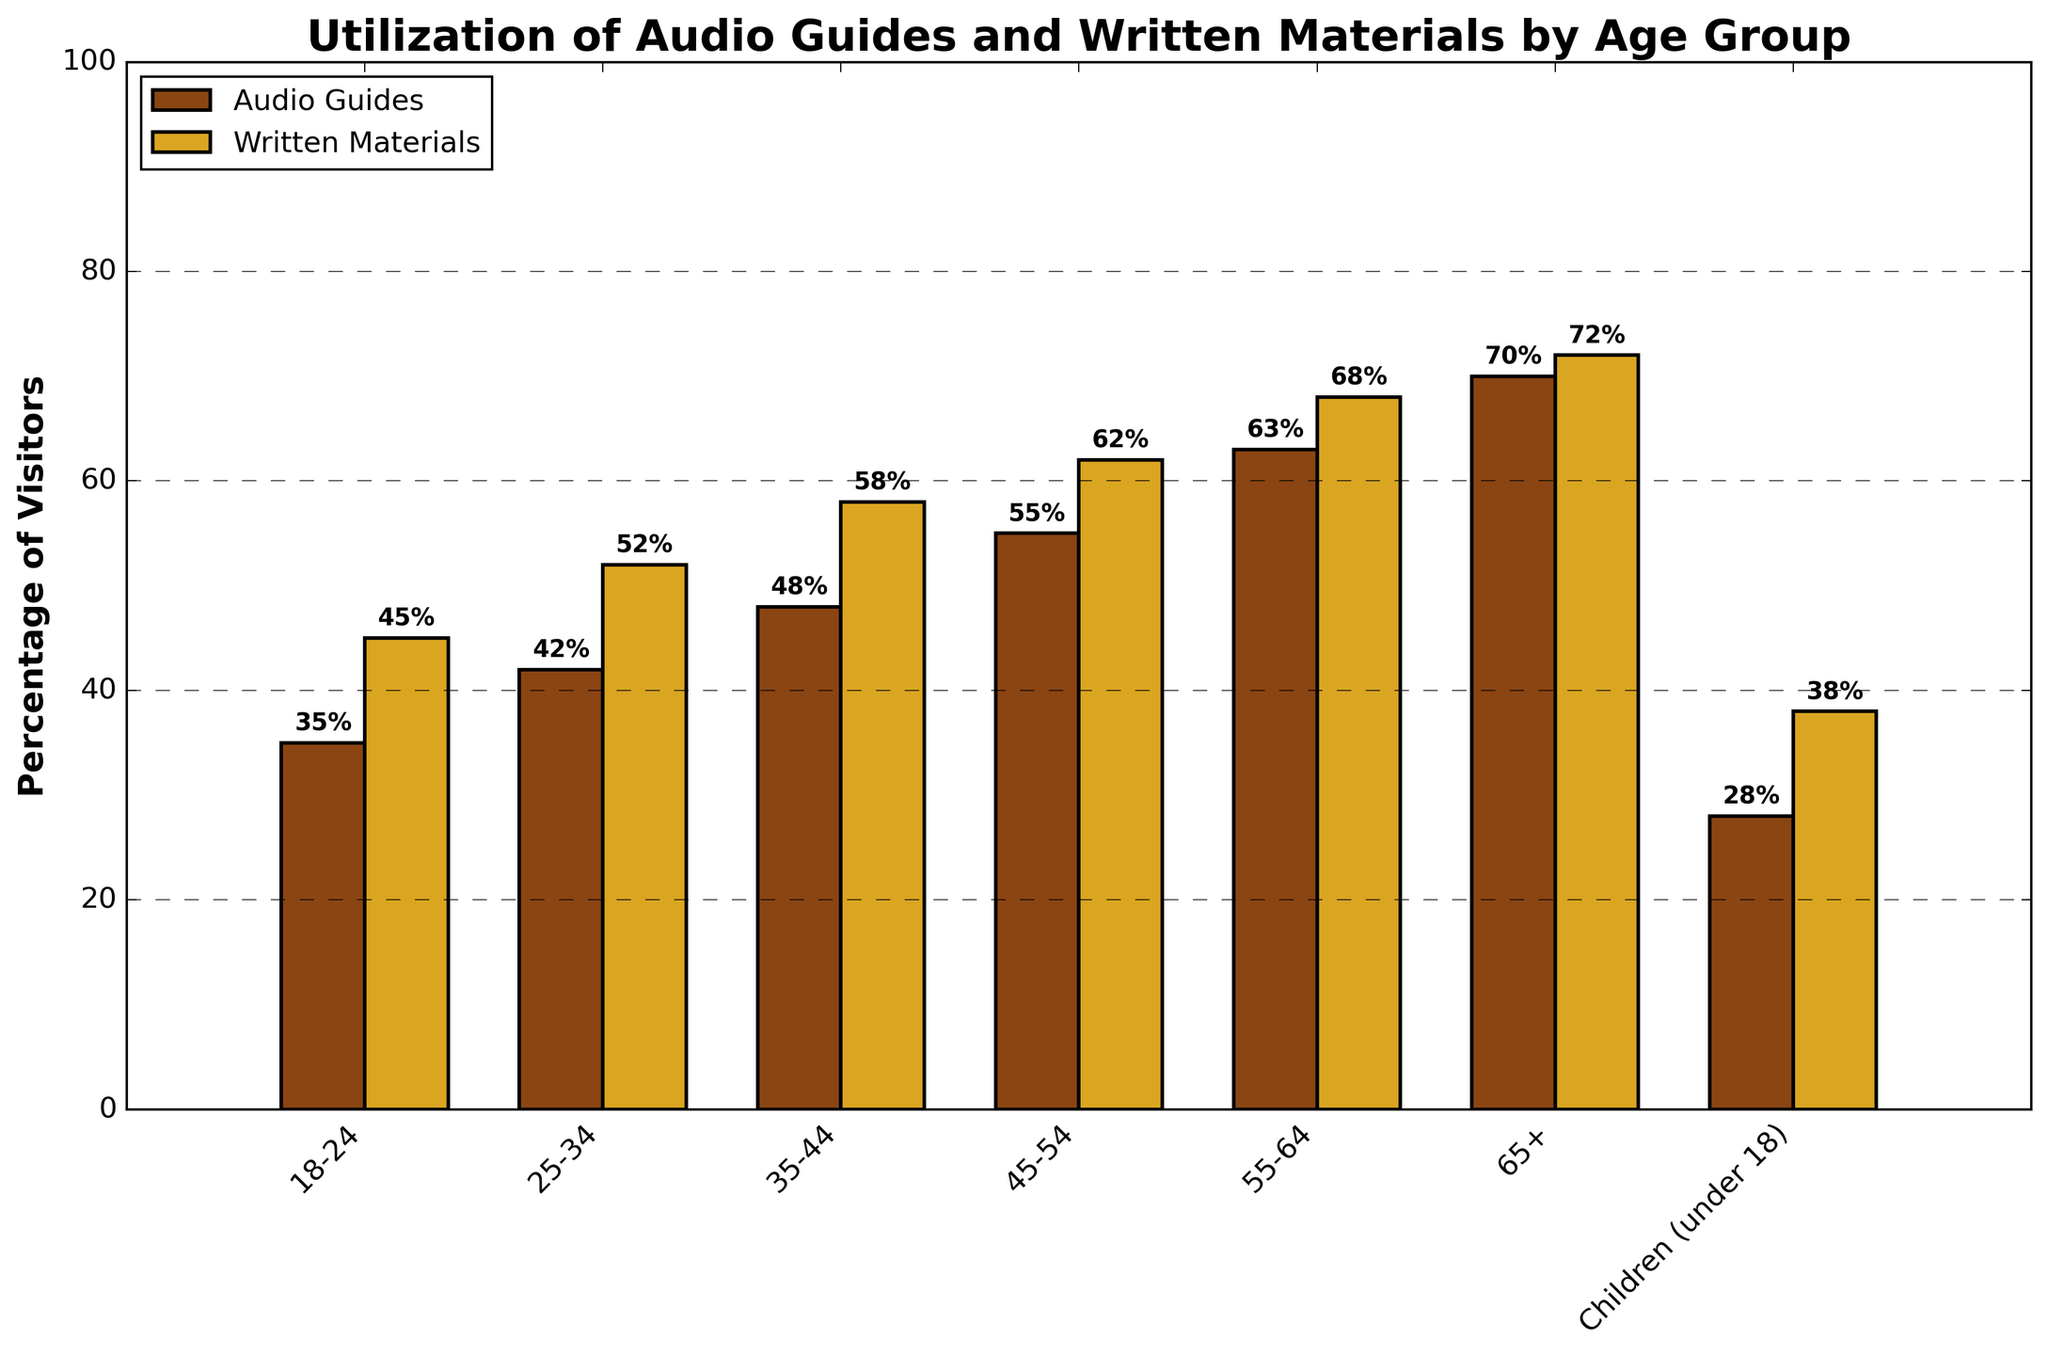Which age group utilizes audio guides the most? By observing the height of the bars representing audio guides, the tallest bar corresponds to the 65+ age group.
Answer: 65+ What is the difference in utilization of written materials between the 18-24 and 55-64 age groups? The percentage for 18-24 is 45 and for 55-64 is 68. The difference is 68 - 45.
Answer: 23 Which resource, audio guides or written materials, is more utilized by the 35-44 age group? By comparing the two bars for the 35-44 age group, the bar representing written materials is taller than the bar representing audio guides.
Answer: Written Materials Between which age groups is there the largest increase in utilization of audio guides? By examining the heights of the bars, the largest increase is between 25-34 (42%) and 35-44 (48%), which is an increase of 6 percentage points.
Answer: Between 25-34 and 35-44 What is the average utilization of written materials for the 18-24 and 25-34 age groups? The percentages for 18-24 and 25-34 age groups are 45 and 52, respectively. The average is (45 + 52) / 2.
Answer: 48.5 By how many percentage points do visitors under 18 utilize written materials more than audio guides? For children under 18, the utilization for written materials is 38% and for audio guides is 28%. The difference is 38 - 28.
Answer: 10 Which age group has the smallest difference between utilization of audio guides and written materials? By calculating the differences for each age group, 65+ has the smallest difference, with a difference of 2 percentage points (72% - 70%).
Answer: 65+ What is the combined utilization percentage of both resources (audio guides and written materials) for the 45-54 age group? The percentages for 45-54 age group are 55% for audio guides and 62% for written materials. The combined total is 55 + 62.
Answer: 117 How does the utilization of written materials change as age increases from 18-24 up to 65+? By following the bars for written materials, the percentage increases stepwise from 45% to 72% as age increases from 18-24 to 65+.
Answer: It increases Which age group shows a higher preference for written materials over audio guides in percentage points? By comparing the differences between written materials and audio guides, the 35-44 age group shows a preference of 10 percentage points (58% - 48%).
Answer: 35-44 